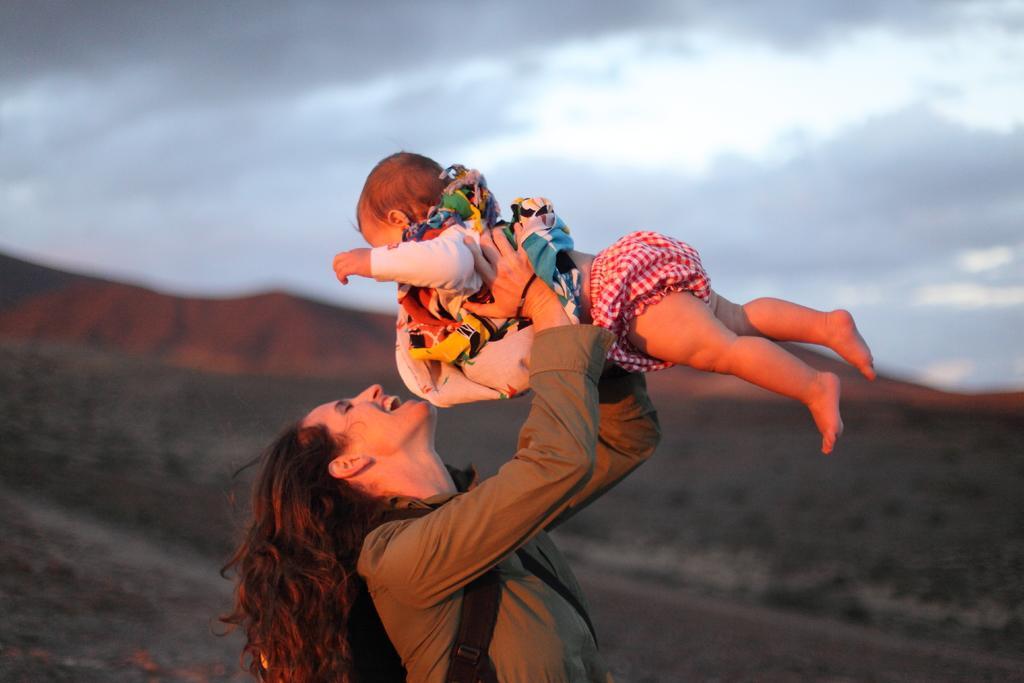Who is the main subject in the image? There is a woman in the image. What is the woman holding in the image? The woman is holding a baby. What can be seen in the background of the image? The sky is visible at the top of the image. What type of fuel is being used by the woman in the image? There is no mention of fuel or any object that would require fuel in the image. 